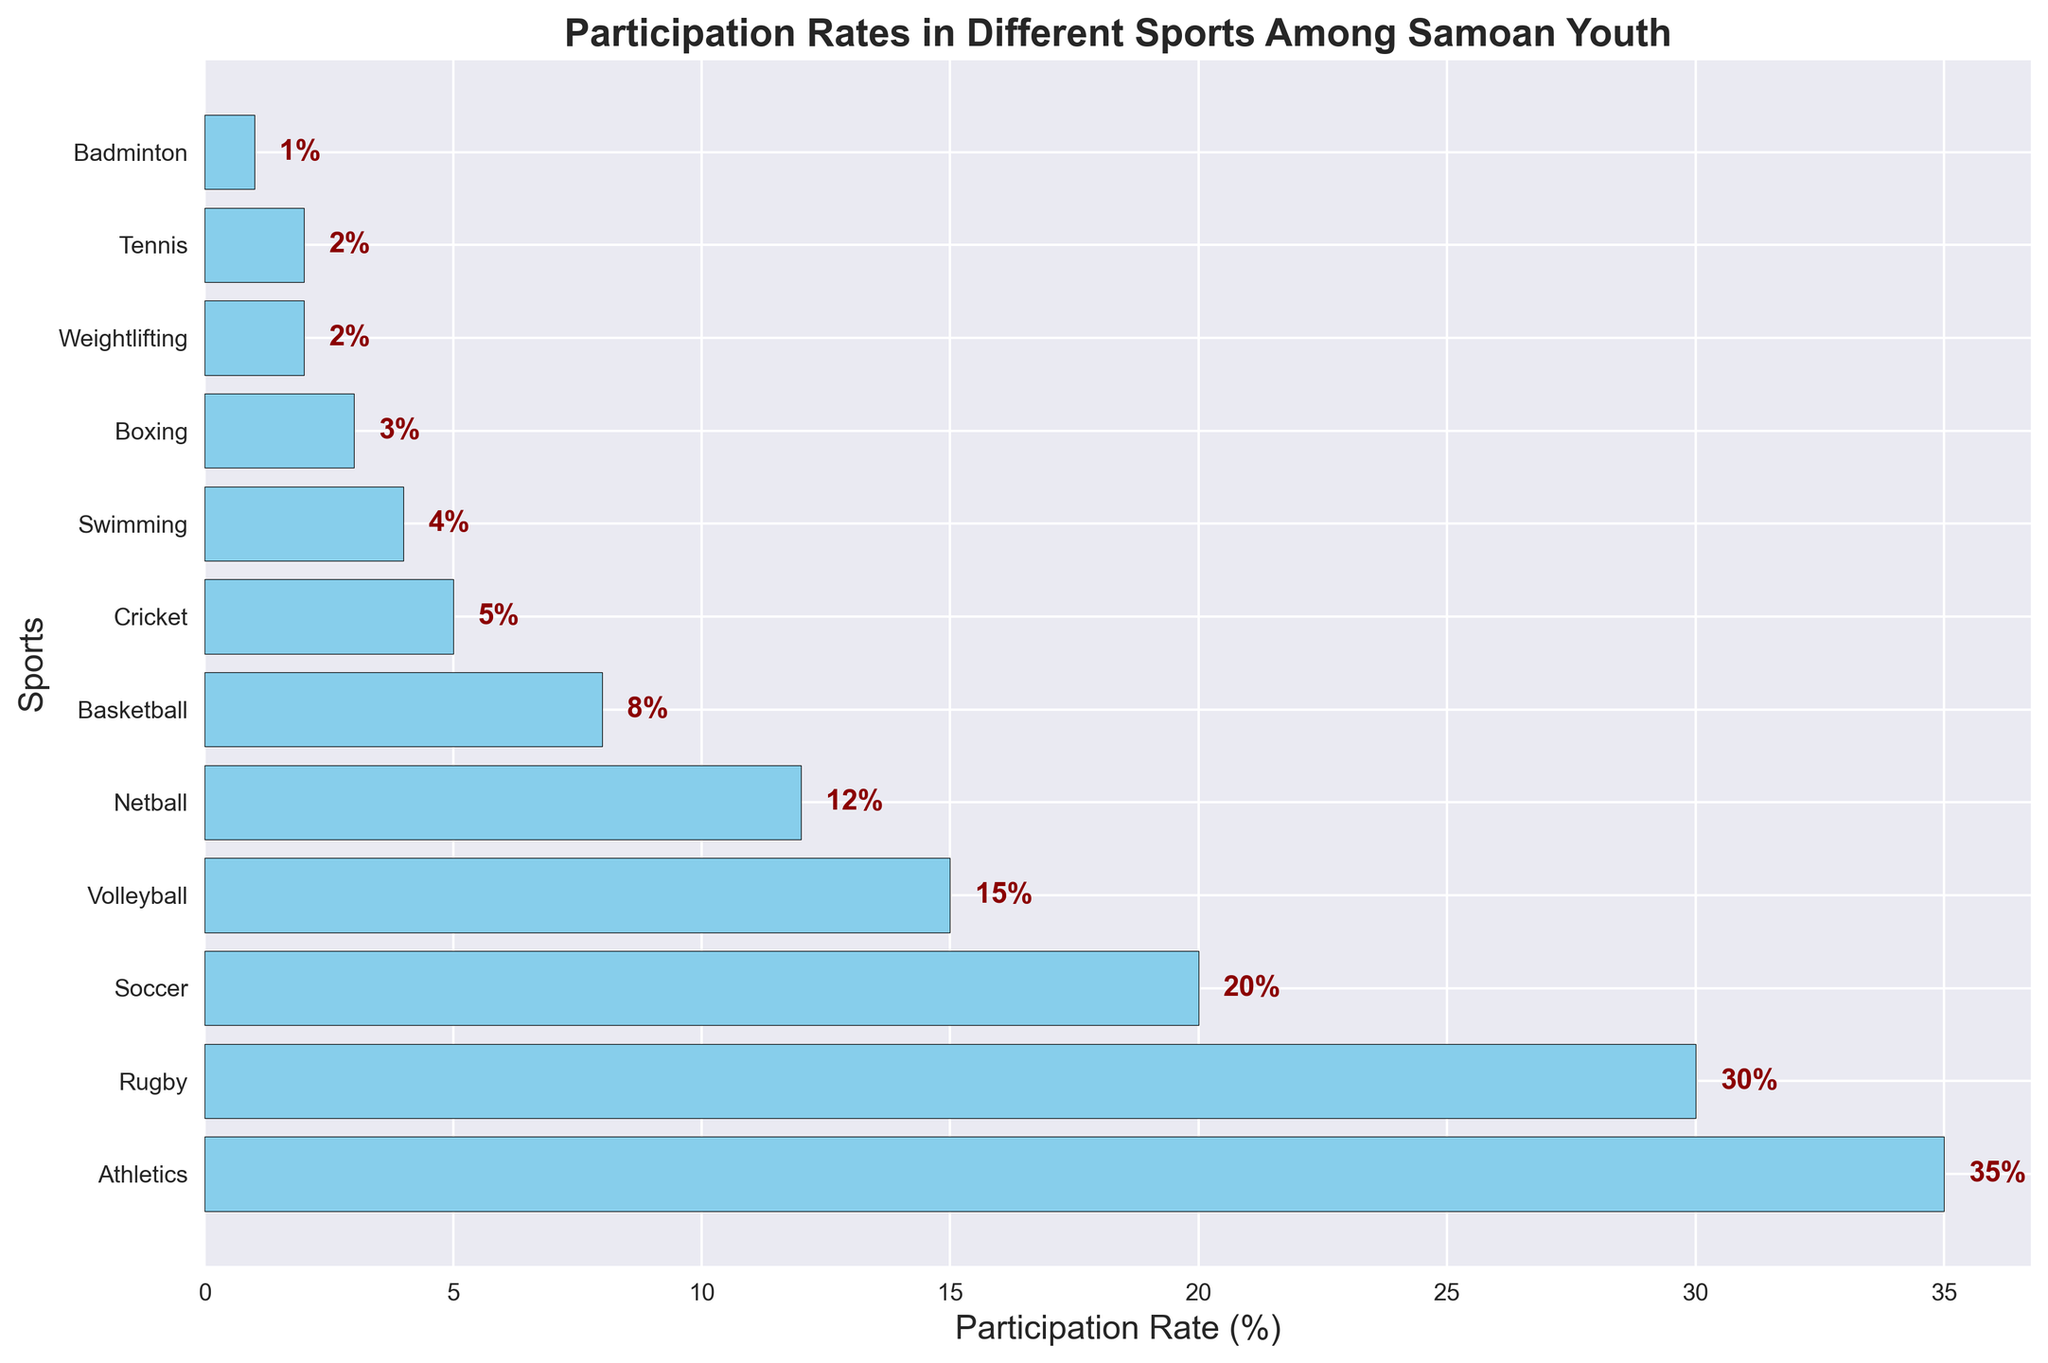What's the participation rate in Athletics? Look at the horizontal bar labeled "Athletics" and read the percentage value or the label on the bar itself. The label reads 35%.
Answer: 35% Which sport has the lowest participation rate? Identify the shortest bar in the bar chart and read the sport's name. The sports with the shortest bars (1%) are Tennis and Badminton.
Answer: Tennis/Badminton How much greater is the participation rate in Rugby compared to Soccer? Find the bars for Rugby and Soccer, read their participation rates (30% and 20% respectively), and subtract the smaller value from the larger one. 30 - 20 = 10.
Answer: 10% Which sports have participation rates above 20%? Look at the bars and identify the ones that exceed the 20% mark. The sports are Athletics (35%) and Rugby (30%).
Answer: Athletics, Rugby What is the combined participation rate of Basketball and Cricket? Find the bars for Basketball and Cricket, read their participation rates, and sum them up. Basketball has 8% and Cricket has 5%. 8 + 5 = 13.
Answer: 13% Is the participation rate in Volleyball closer to that of Soccer or Netball? Locate the bars for Volleyball, Soccer, and Netball. The participation rates are Volleyball (15%), Soccer (20%), and Netball (12%). Calculate the differences: 15 - 20 = -5 (absolute value 5), and 15 - 12 = 3. Volleyball is closer to Netball.
Answer: Netball What percentage of youths do not participate in the top three sports, Athletics, Rugby, and Soccer? Sum the participation rates of the top three sports and subtract from 100%. The rates are Athletics (35%), Rugby (30%), and Soccer (20%). 35 + 30 + 20 = 85. 100 - 85 = 15.
Answer: 15% How does the participation rate in Boxing compare to that in Swimming? Read the participation rates of Boxing and Swimming from their respective bars. Boxing is at 3% and Swimming is at 4%. Compare the values: 3 < 4.
Answer: Boxing is less than Swimming Which sport has the closest participation rate to 10%? Look for the bar(s) whose value is closest to 10%. Netball has a participation rate of 12%, which is the closest to 10%.
Answer: Netball What’s the total participation rate for sports with less than 10% participation? Identify sports with bars under 10% and add their participation rates: Basketball (8%), Cricket (5%), Swimming (4%), Boxing (3%), Weightlifting (2%), Tennis (2%), and Badminton (1%). 8 + 5 + 4 + 3 + 2 + 2 + 1 = 25.
Answer: 25% 